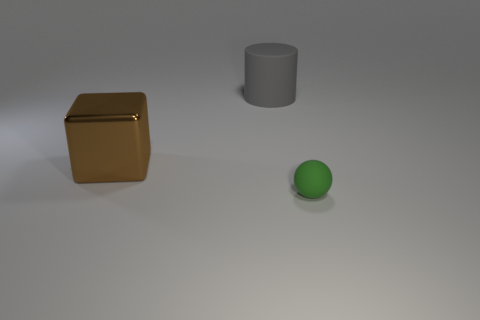Add 1 gray matte cylinders. How many objects exist? 4 Subtract all spheres. How many objects are left? 2 Add 1 large blocks. How many large blocks are left? 2 Add 2 tiny green balls. How many tiny green balls exist? 3 Subtract 0 brown spheres. How many objects are left? 3 Subtract all big blocks. Subtract all gray metallic objects. How many objects are left? 2 